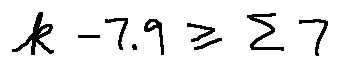<formula> <loc_0><loc_0><loc_500><loc_500>k - 7 . 9 \geq \sum 7</formula> 